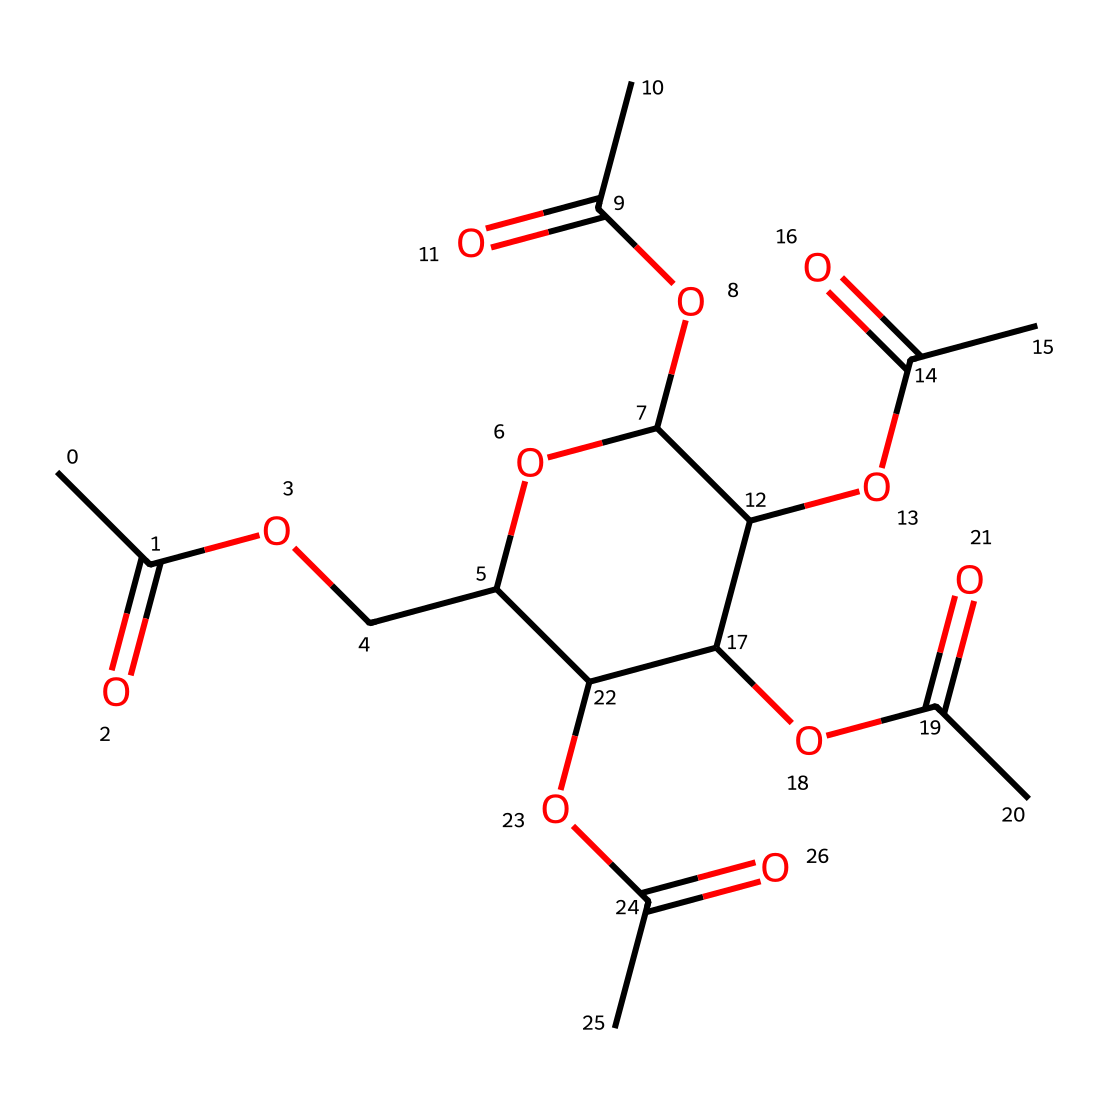What is the molecular formula for cellulose acetate? To derive the molecular formula, we identify and count the types of atoms present in the SMILES representation. Analyzing the structure reveals carbon (C), hydrogen (H), and oxygen (O) atoms. We find that there are 24 carbon atoms, 38 hydrogen atoms, and 10 oxygen atoms, leading to the formula C24H38O10.
Answer: C24H38O10 How many ester functional groups are present in this molecule? Examining cellulose acetate’s structure, we identify the ester functional groups, which are characterized by the presence of a carbonyl group (C=O) adjacent to an ether group (C-O). By analyzing the structure, we can count six such groups in cellulose acetate.
Answer: 6 Which part of the structure indicates its use as an ester? The presence of carbonyl groups (C=O) connected to oxygens (C-O) indicates the functionality of this molecule as an ester. This specific configuration is essential for producing ester compounds, which are known for their characteristic properties.
Answer: carbonyl and ether groups What type of reaction is primarily responsible for the formation of cellulose acetate? The formation of cellulose acetate involves an esterification reaction, where cellulose reacts with acetic anhydride or acetic acid, resulting in the formation of the ester bonds present in cellulose acetate.
Answer: esterification How many rings are present in the structure? Analyzing the given SMILES representation, we see that there is one cyclic structure that contains several oxygen atoms; this indicates the presence of a ring structure in cellulose acetate.
Answer: 1 